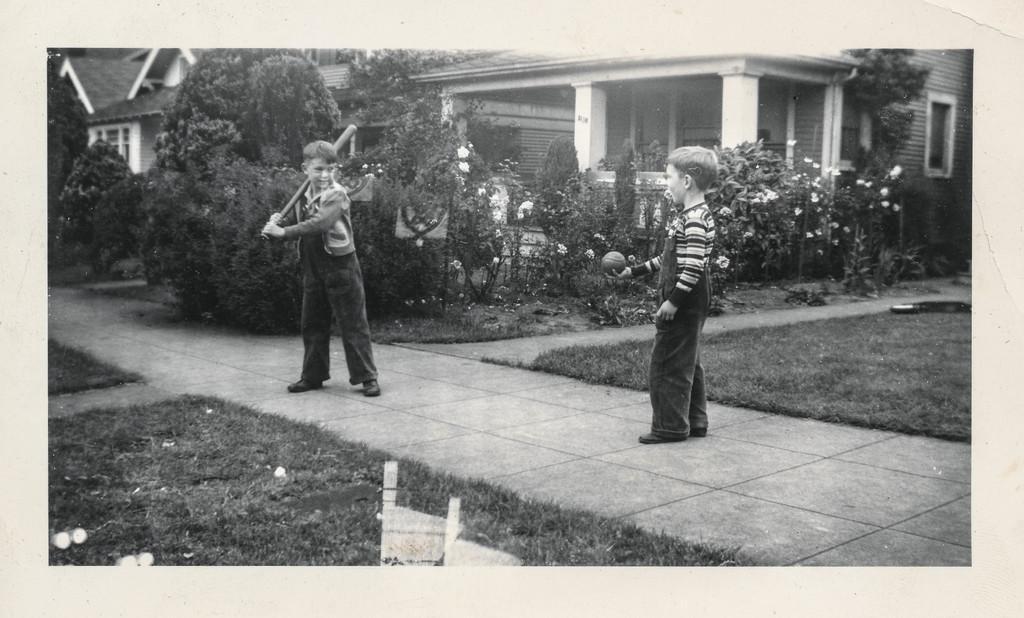Describe this image in one or two sentences. In this image there are two boys standing on the pavement in which one of them is holding bat, beside them there are so many garden plants and some buildings. 